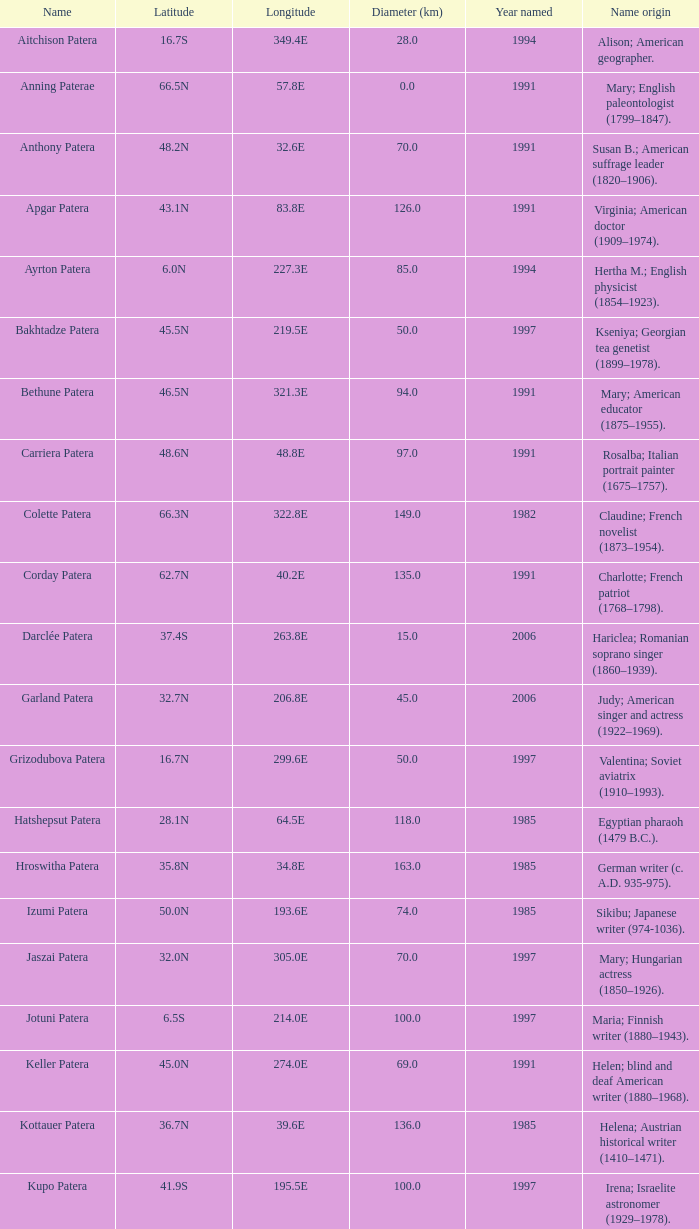What is the longitude of the feature named Razia Patera?  197.8E. 